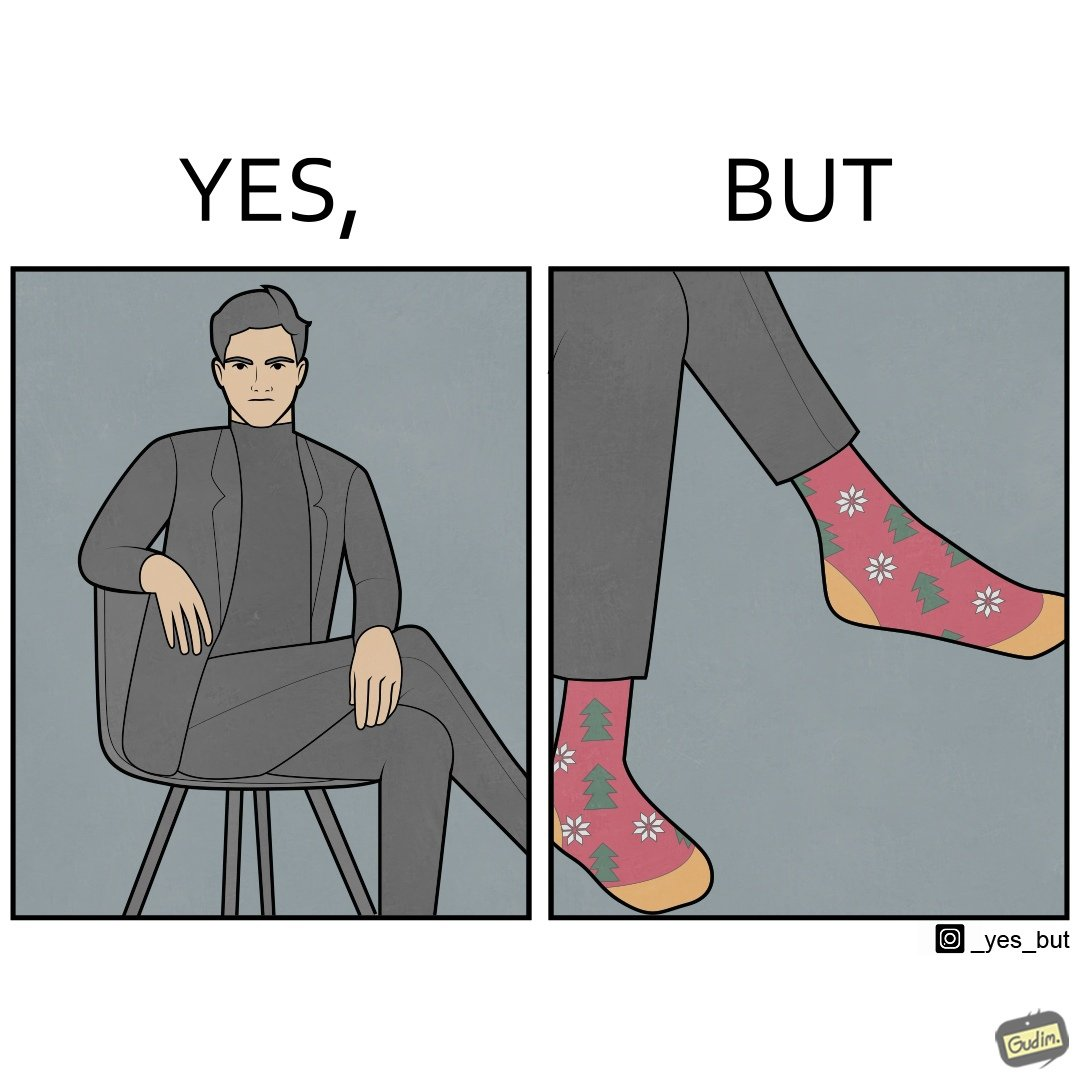Does this image contain satire or humor? Yes, this image is satirical. 